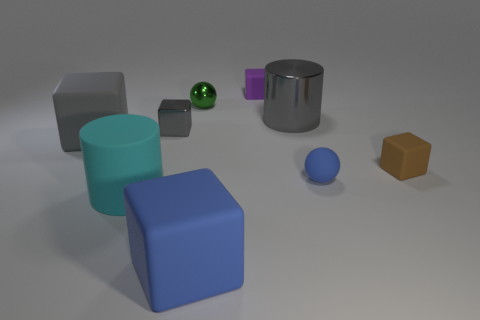There is a big cylinder right of the large blue thing; what is it made of?
Keep it short and to the point. Metal. What is the color of the metal block that is the same size as the blue rubber sphere?
Provide a succinct answer. Gray. How many other things are the same shape as the tiny brown matte thing?
Provide a succinct answer. 4. Is the gray cylinder the same size as the cyan rubber cylinder?
Your answer should be very brief. Yes. Is the number of large blocks behind the small blue sphere greater than the number of big gray shiny things that are left of the large cyan object?
Your answer should be very brief. Yes. How many other objects are the same size as the metal cylinder?
Ensure brevity in your answer.  3. Does the large matte thing right of the tiny green thing have the same color as the small matte ball?
Ensure brevity in your answer.  Yes. Are there more gray shiny cubes that are behind the large gray block than tiny purple metal blocks?
Provide a short and direct response. Yes. Is there any other thing that is the same color as the rubber ball?
Provide a succinct answer. Yes. There is a big gray object right of the large gray thing on the left side of the green object; what is its shape?
Your response must be concise. Cylinder. 